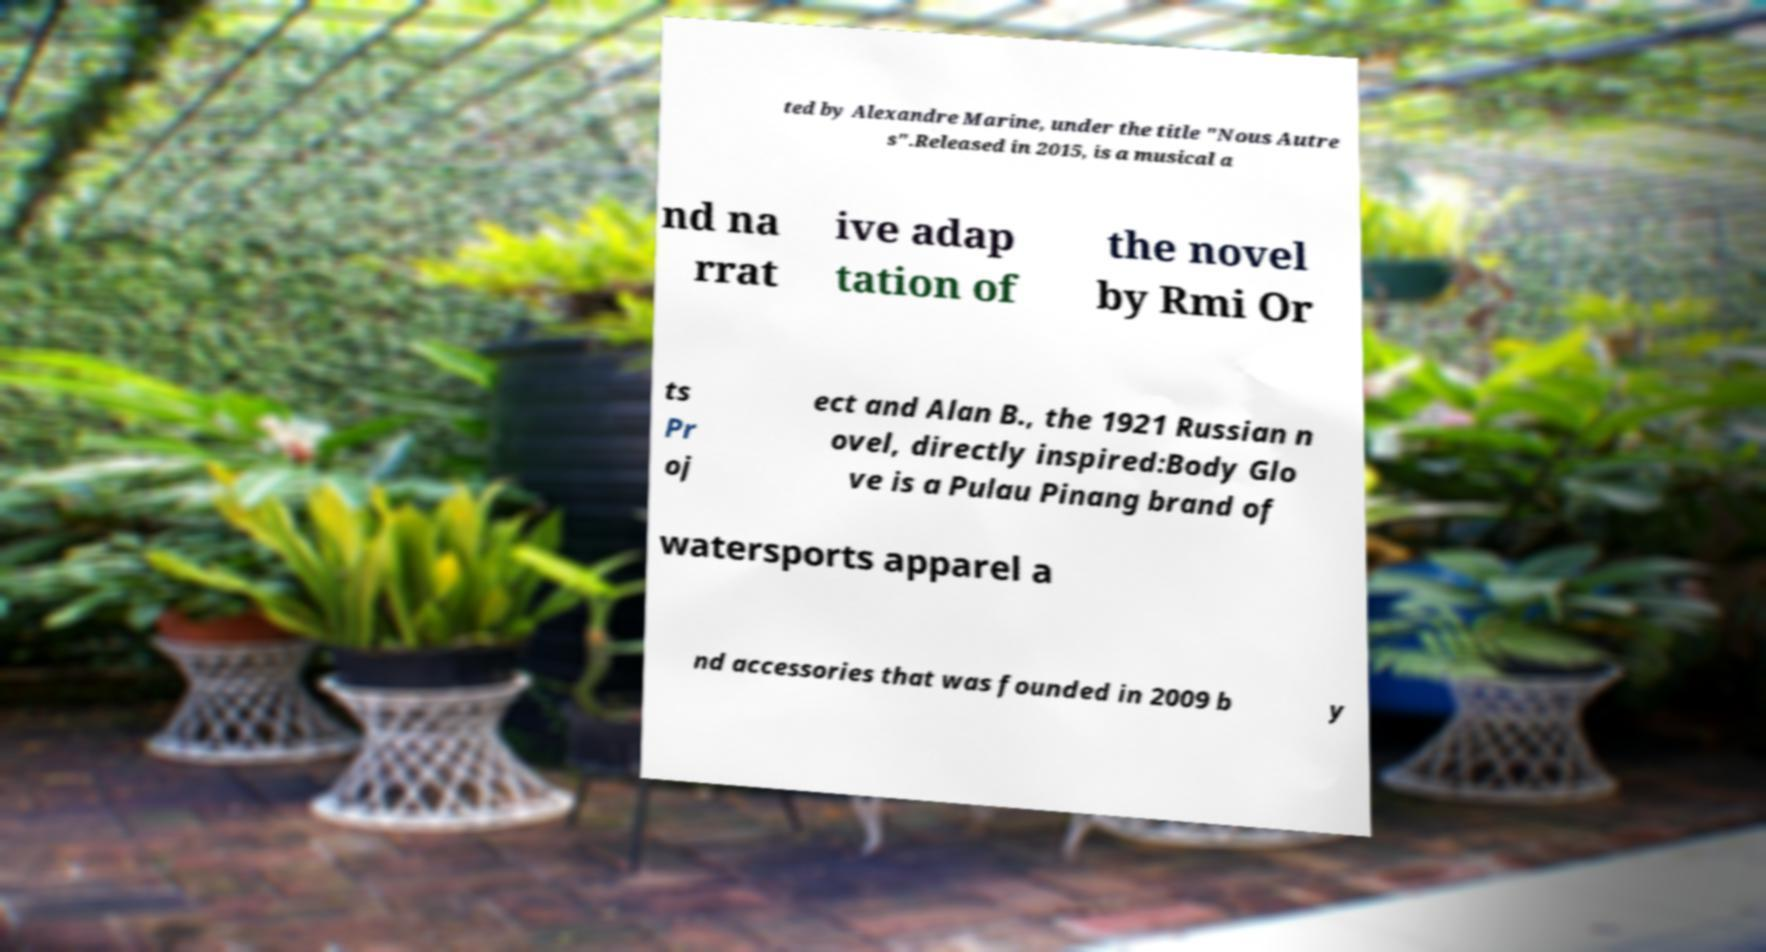Can you read and provide the text displayed in the image?This photo seems to have some interesting text. Can you extract and type it out for me? ted by Alexandre Marine, under the title "Nous Autre s".Released in 2015, is a musical a nd na rrat ive adap tation of the novel by Rmi Or ts Pr oj ect and Alan B., the 1921 Russian n ovel, directly inspired:Body Glo ve is a Pulau Pinang brand of watersports apparel a nd accessories that was founded in 2009 b y 